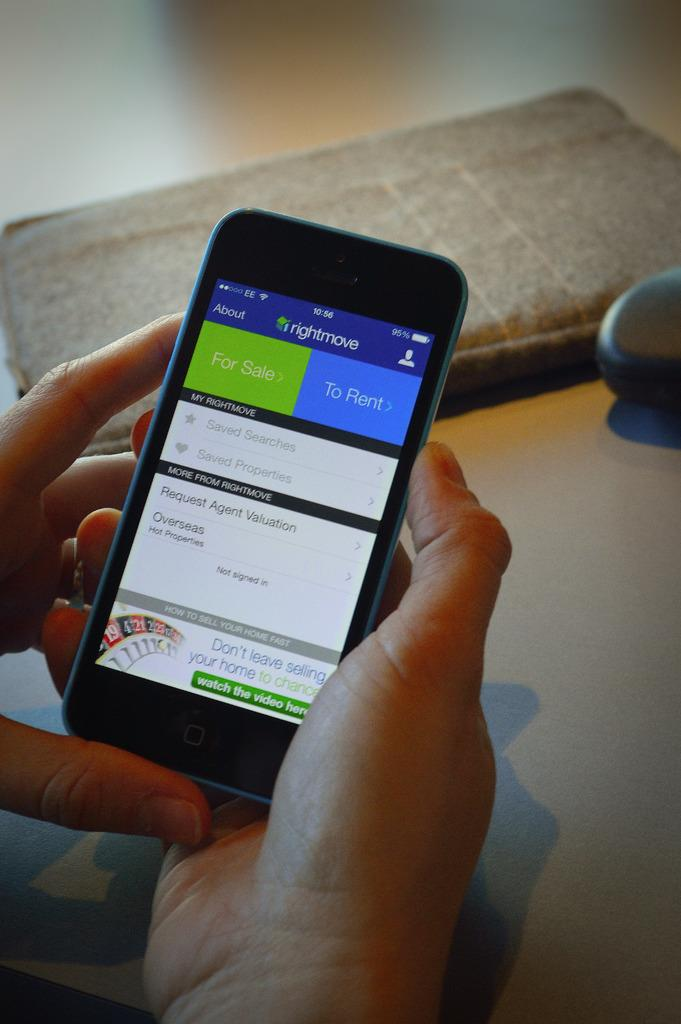What is the person holding in the image? The person's hands are holding a cellphone in the image. What can be seen on the floor in the image? There are objects on the floor in the image. How many fish are swimming in the image? There are no fish present in the image. What type of yoke is being used by the person in the image? There is no yoke present in the image, and the person is not performing any activity that would require a yoke. 